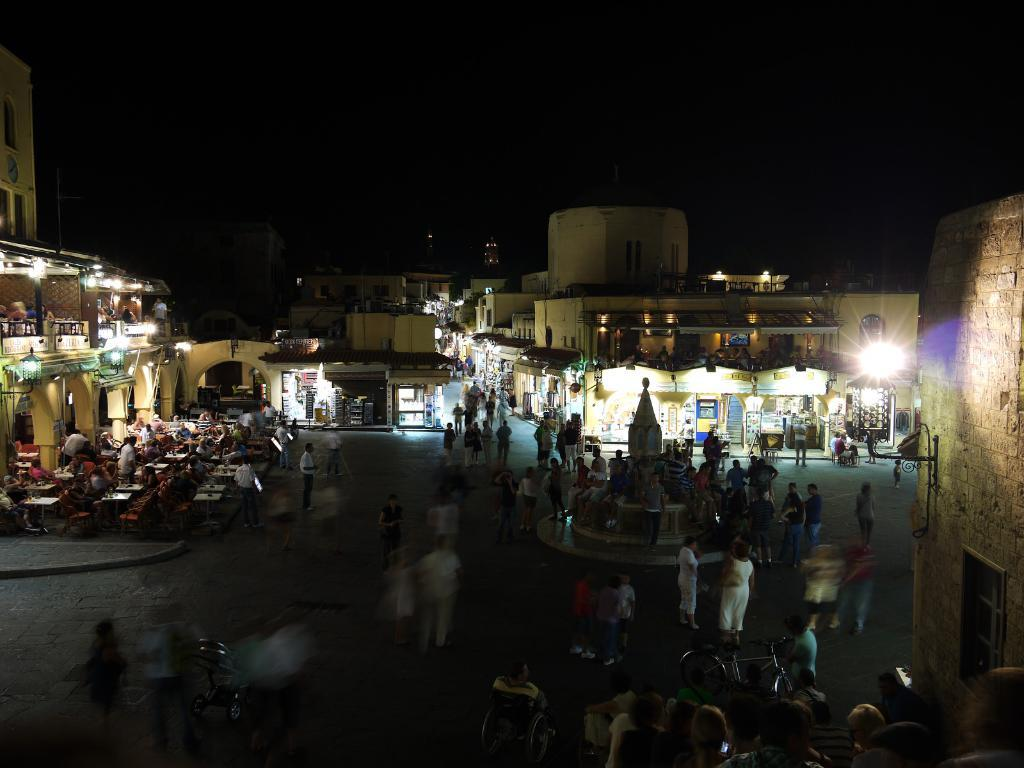How many people are in the group visible in the image? There is a group of people in the image, but the exact number cannot be determined from the provided facts. What type of structures are present in the image? There are buildings in the image. What type of furniture is visible in the image? There are tables and chairs in the image. What feature can be seen on the buildings in the image? There are lights on the buildings. What is visible at the top of the image? The sky is visible at the top of the image. What is located at the bottom of the image? There is a road at the bottom of the image. Where is the faucet located in the image? There is no faucet present in the image. What type of advice does the governor give to the people in the image? There is no governor or advice-giving in the image; it features a group of people, buildings, tables and chairs, lights, sky, and a road. 